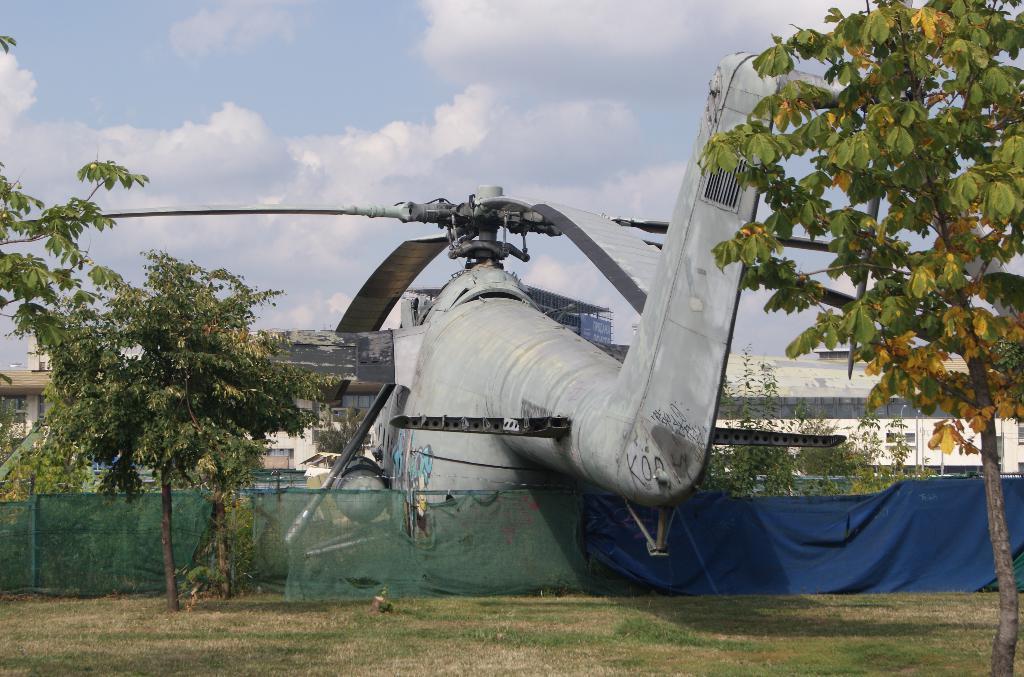Describe this image in one or two sentences. In this image in the front there's grass on the ground and in the center there are trees and there is a fence. In the background there is a helicopter, there are buildings and trees. In the front on the right side there is a tree and the sky is cloudy. 